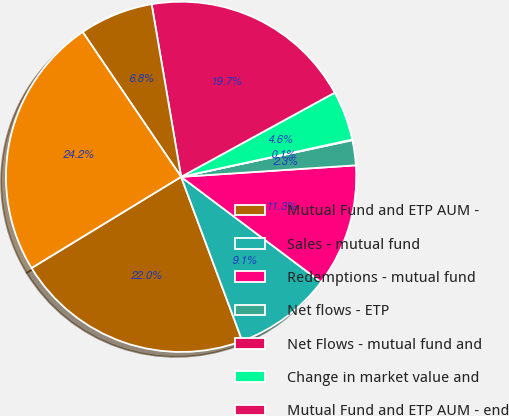Convert chart to OTSL. <chart><loc_0><loc_0><loc_500><loc_500><pie_chart><fcel>Mutual Fund and ETP AUM -<fcel>Sales - mutual fund<fcel>Redemptions - mutual fund<fcel>Net flows - ETP<fcel>Net Flows - mutual fund and<fcel>Change in market value and<fcel>Mutual Fund and ETP AUM - end<fcel>Talcott Resolution life and<fcel>Hartford Funds AUM<nl><fcel>21.96%<fcel>9.06%<fcel>11.31%<fcel>2.31%<fcel>0.06%<fcel>4.56%<fcel>19.71%<fcel>6.81%<fcel>24.21%<nl></chart> 